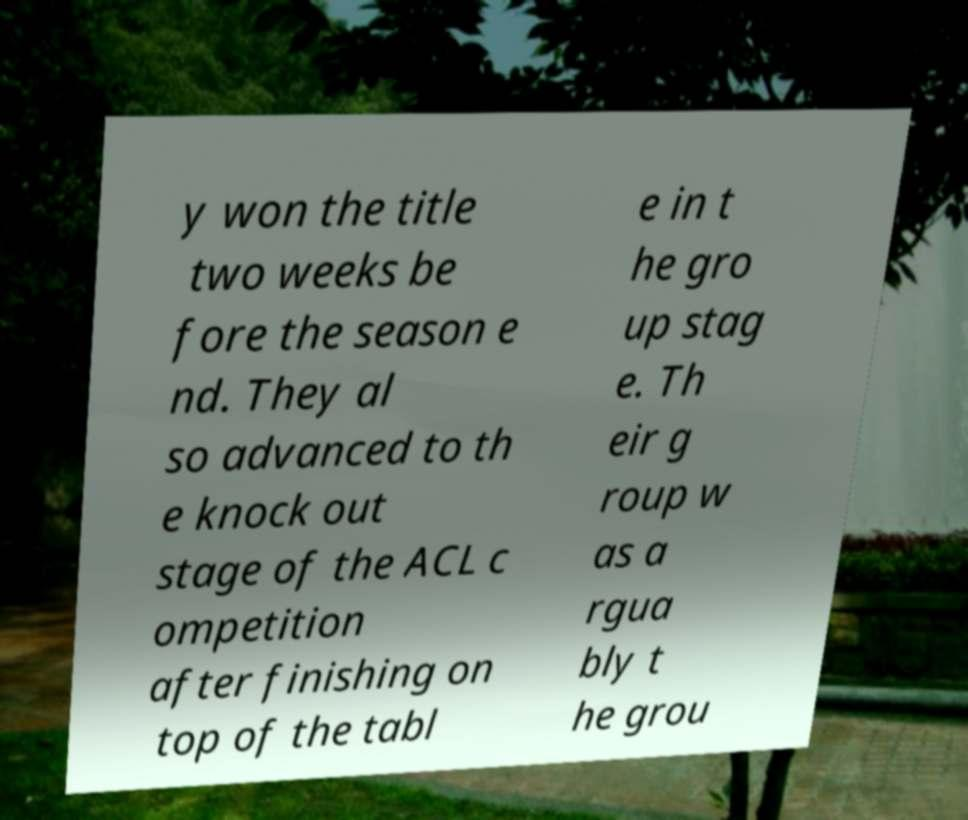There's text embedded in this image that I need extracted. Can you transcribe it verbatim? y won the title two weeks be fore the season e nd. They al so advanced to th e knock out stage of the ACL c ompetition after finishing on top of the tabl e in t he gro up stag e. Th eir g roup w as a rgua bly t he grou 